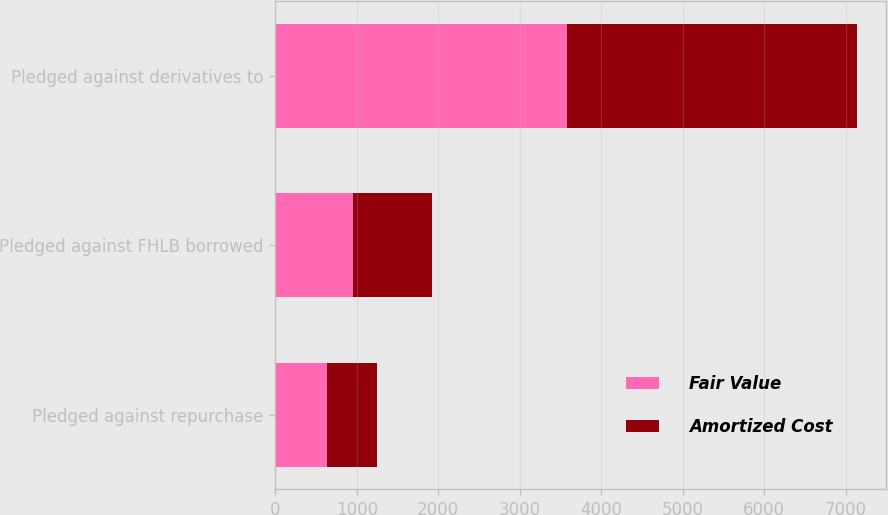<chart> <loc_0><loc_0><loc_500><loc_500><stacked_bar_chart><ecel><fcel>Pledged against repurchase<fcel>Pledged against FHLB borrowed<fcel>Pledged against derivatives to<nl><fcel>Fair Value<fcel>631<fcel>953<fcel>3575<nl><fcel>Amortized Cost<fcel>620<fcel>972<fcel>3563<nl></chart> 